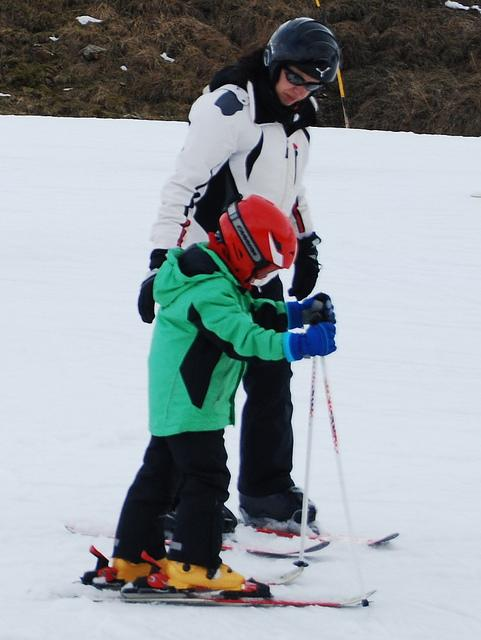Why are his skis so small? child 